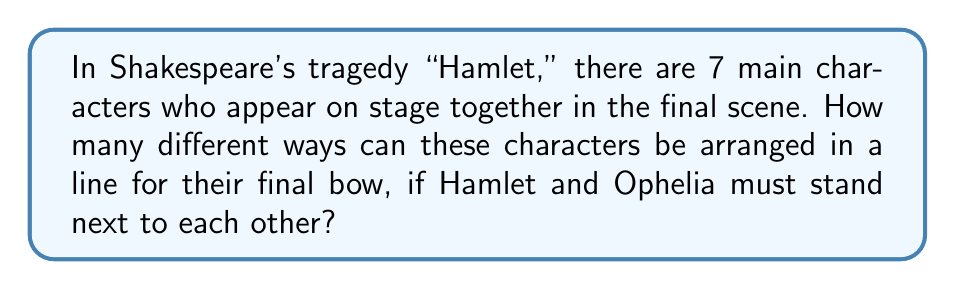Give your solution to this math problem. Let's approach this step-by-step:

1) First, we consider Hamlet and Ophelia as a single unit. This reduces our problem to arranging 6 units (the Hamlet-Ophelia pair and the other 5 characters).

2) The number of ways to arrange 6 units is simply 6!, which is:

   $$6! = 6 \times 5 \times 4 \times 3 \times 2 \times 1 = 720$$

3) However, for each of these 720 arrangements, Hamlet and Ophelia can be arranged in 2 ways within their unit (Hamlet-Ophelia or Ophelia-Hamlet).

4) Therefore, we need to multiply our result by 2:

   $$720 \times 2 = 1440$$

5) This can also be written as:

   $$2 \times 6! = 2 \times 720 = 1440$$

Thus, there are 1440 different ways to arrange the 7 characters with Hamlet and Ophelia always next to each other.
Answer: 1440 